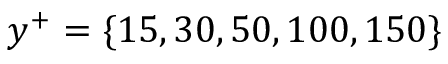Convert formula to latex. <formula><loc_0><loc_0><loc_500><loc_500>y ^ { + } = \{ 1 5 , 3 0 , 5 0 , 1 0 0 , 1 5 0 \}</formula> 